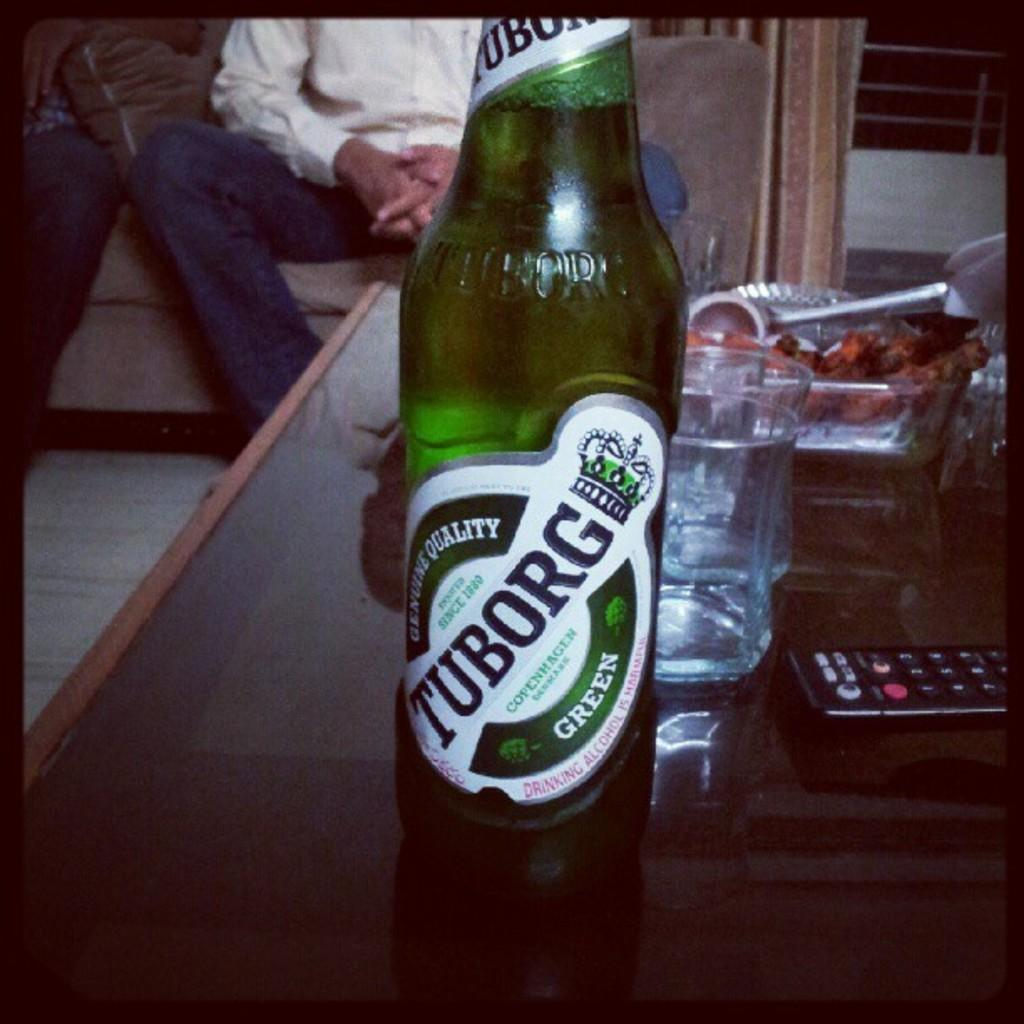<image>
Relay a brief, clear account of the picture shown. A beer called Tuborg sits on a table 